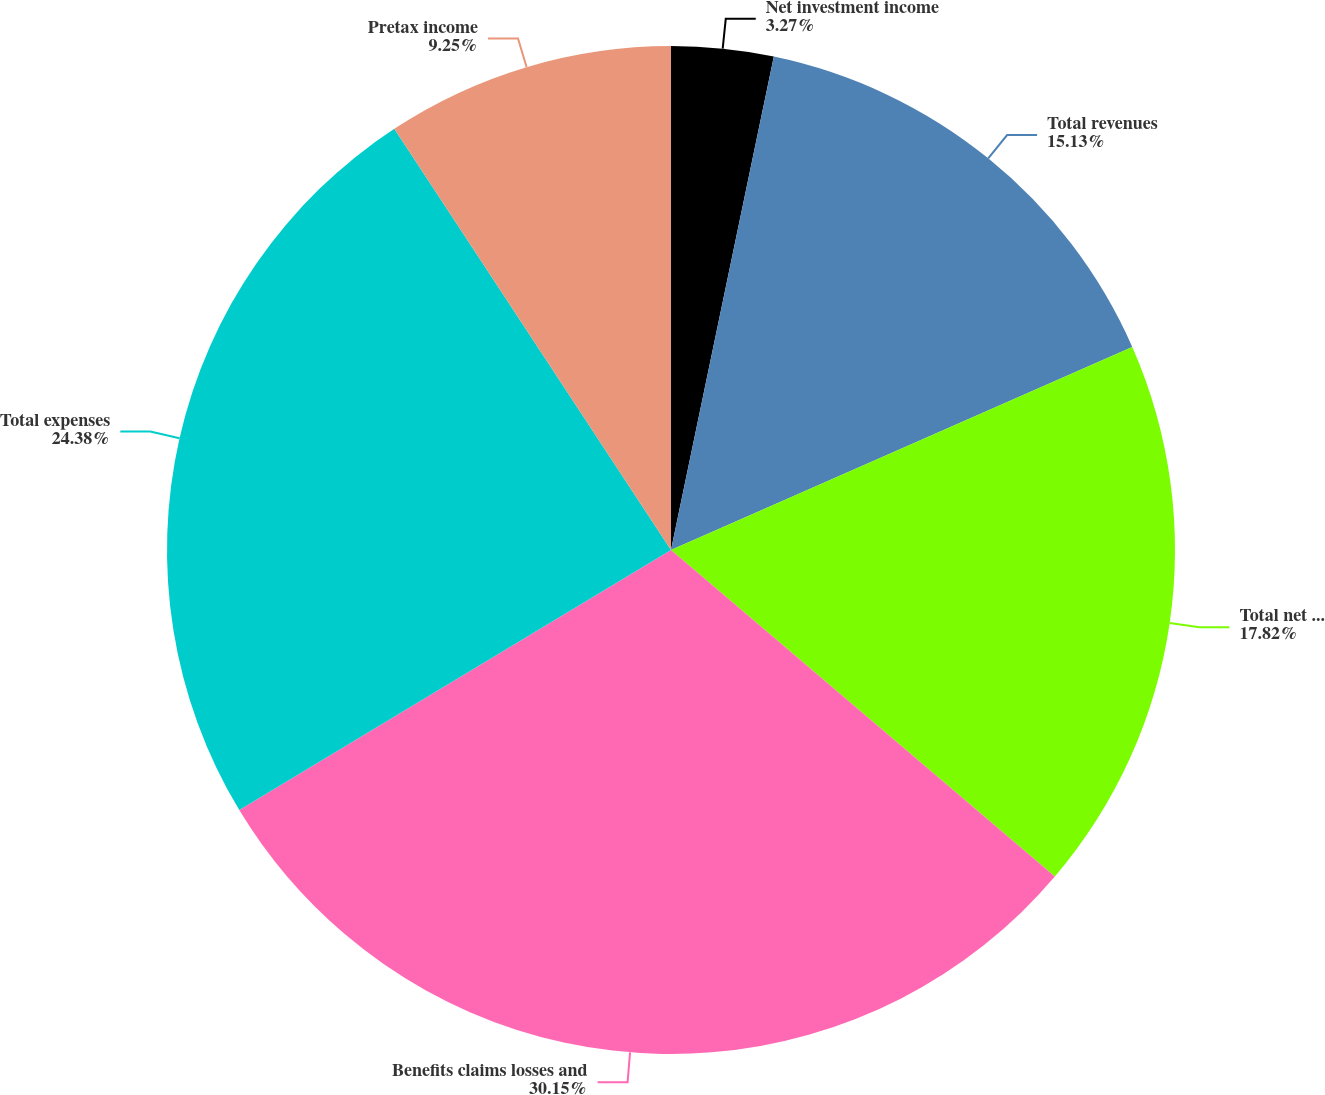Convert chart. <chart><loc_0><loc_0><loc_500><loc_500><pie_chart><fcel>Net investment income<fcel>Total revenues<fcel>Total net revenues<fcel>Benefits claims losses and<fcel>Total expenses<fcel>Pretax income<nl><fcel>3.27%<fcel>15.13%<fcel>17.82%<fcel>30.15%<fcel>24.38%<fcel>9.25%<nl></chart> 